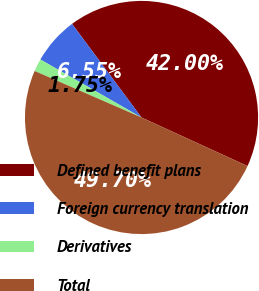<chart> <loc_0><loc_0><loc_500><loc_500><pie_chart><fcel>Defined benefit plans<fcel>Foreign currency translation<fcel>Derivatives<fcel>Total<nl><fcel>42.0%<fcel>6.55%<fcel>1.75%<fcel>49.7%<nl></chart> 